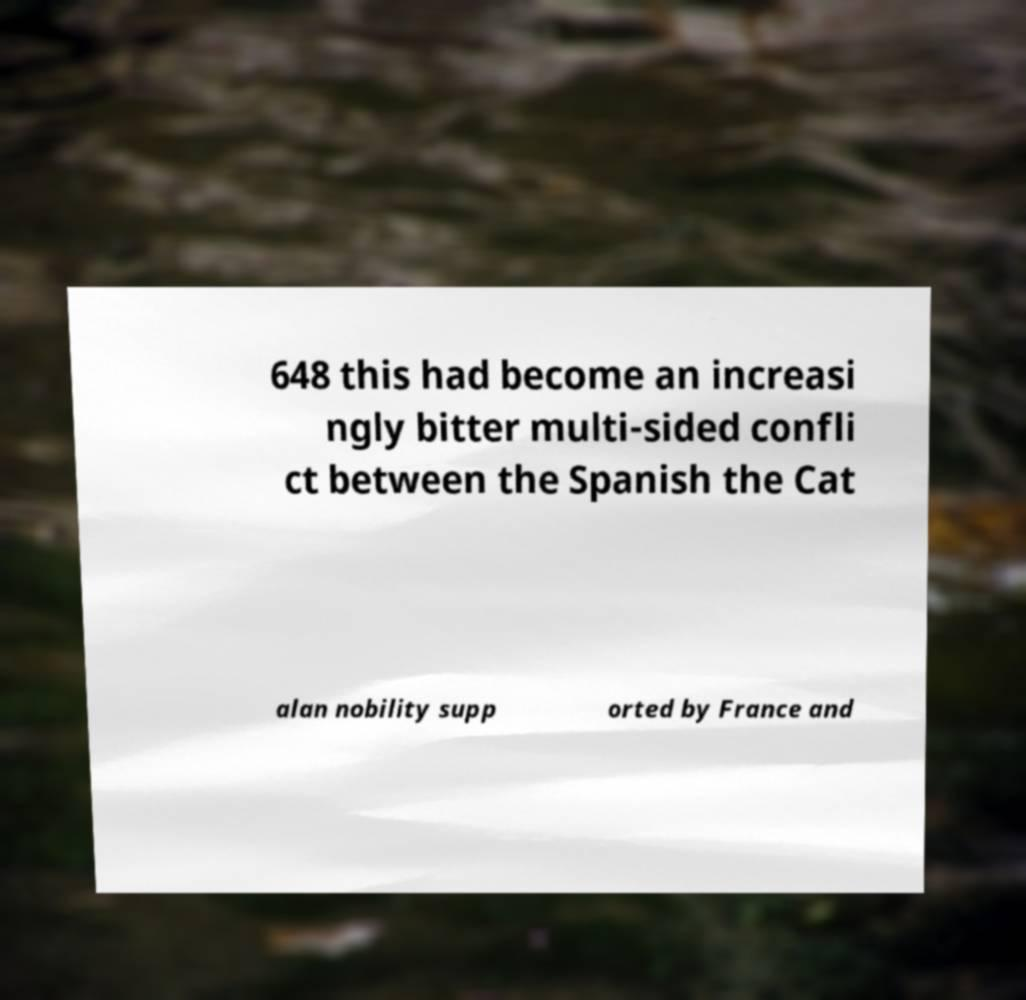Could you extract and type out the text from this image? 648 this had become an increasi ngly bitter multi-sided confli ct between the Spanish the Cat alan nobility supp orted by France and 